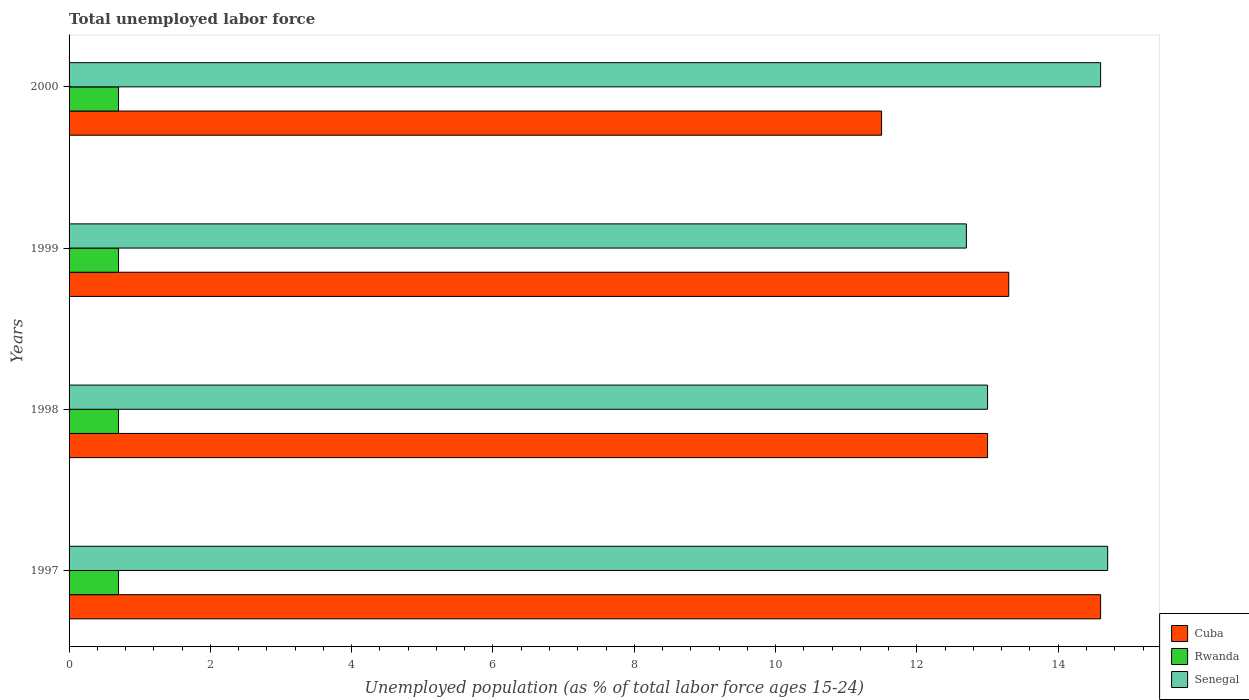How many different coloured bars are there?
Your answer should be very brief. 3. What is the label of the 4th group of bars from the top?
Provide a short and direct response. 1997. In how many cases, is the number of bars for a given year not equal to the number of legend labels?
Your response must be concise. 0. What is the percentage of unemployed population in in Rwanda in 1997?
Your answer should be compact. 0.7. Across all years, what is the maximum percentage of unemployed population in in Senegal?
Ensure brevity in your answer.  14.7. Across all years, what is the minimum percentage of unemployed population in in Senegal?
Your response must be concise. 12.7. In which year was the percentage of unemployed population in in Rwanda maximum?
Your response must be concise. 1997. In which year was the percentage of unemployed population in in Rwanda minimum?
Offer a terse response. 1997. What is the total percentage of unemployed population in in Cuba in the graph?
Provide a succinct answer. 52.4. What is the average percentage of unemployed population in in Cuba per year?
Provide a short and direct response. 13.1. In the year 2000, what is the difference between the percentage of unemployed population in in Senegal and percentage of unemployed population in in Rwanda?
Offer a terse response. 13.9. What is the ratio of the percentage of unemployed population in in Cuba in 1997 to that in 1999?
Your response must be concise. 1.1. Is the percentage of unemployed population in in Senegal in 1997 less than that in 1999?
Keep it short and to the point. No. What is the difference between the highest and the second highest percentage of unemployed population in in Senegal?
Give a very brief answer. 0.1. What is the difference between the highest and the lowest percentage of unemployed population in in Rwanda?
Your answer should be compact. 0. In how many years, is the percentage of unemployed population in in Senegal greater than the average percentage of unemployed population in in Senegal taken over all years?
Make the answer very short. 2. Is the sum of the percentage of unemployed population in in Cuba in 1997 and 1998 greater than the maximum percentage of unemployed population in in Rwanda across all years?
Provide a succinct answer. Yes. What does the 1st bar from the top in 1999 represents?
Give a very brief answer. Senegal. What does the 3rd bar from the bottom in 1997 represents?
Give a very brief answer. Senegal. Is it the case that in every year, the sum of the percentage of unemployed population in in Senegal and percentage of unemployed population in in Cuba is greater than the percentage of unemployed population in in Rwanda?
Your answer should be very brief. Yes. How many bars are there?
Give a very brief answer. 12. Are all the bars in the graph horizontal?
Give a very brief answer. Yes. What is the difference between two consecutive major ticks on the X-axis?
Provide a short and direct response. 2. Where does the legend appear in the graph?
Keep it short and to the point. Bottom right. How many legend labels are there?
Make the answer very short. 3. What is the title of the graph?
Your answer should be compact. Total unemployed labor force. Does "Armenia" appear as one of the legend labels in the graph?
Your response must be concise. No. What is the label or title of the X-axis?
Make the answer very short. Unemployed population (as % of total labor force ages 15-24). What is the label or title of the Y-axis?
Keep it short and to the point. Years. What is the Unemployed population (as % of total labor force ages 15-24) of Cuba in 1997?
Your response must be concise. 14.6. What is the Unemployed population (as % of total labor force ages 15-24) of Rwanda in 1997?
Make the answer very short. 0.7. What is the Unemployed population (as % of total labor force ages 15-24) in Senegal in 1997?
Provide a succinct answer. 14.7. What is the Unemployed population (as % of total labor force ages 15-24) of Rwanda in 1998?
Your response must be concise. 0.7. What is the Unemployed population (as % of total labor force ages 15-24) of Senegal in 1998?
Make the answer very short. 13. What is the Unemployed population (as % of total labor force ages 15-24) in Cuba in 1999?
Provide a succinct answer. 13.3. What is the Unemployed population (as % of total labor force ages 15-24) of Rwanda in 1999?
Offer a very short reply. 0.7. What is the Unemployed population (as % of total labor force ages 15-24) of Senegal in 1999?
Ensure brevity in your answer.  12.7. What is the Unemployed population (as % of total labor force ages 15-24) in Rwanda in 2000?
Give a very brief answer. 0.7. What is the Unemployed population (as % of total labor force ages 15-24) in Senegal in 2000?
Make the answer very short. 14.6. Across all years, what is the maximum Unemployed population (as % of total labor force ages 15-24) of Cuba?
Provide a short and direct response. 14.6. Across all years, what is the maximum Unemployed population (as % of total labor force ages 15-24) in Rwanda?
Make the answer very short. 0.7. Across all years, what is the maximum Unemployed population (as % of total labor force ages 15-24) in Senegal?
Make the answer very short. 14.7. Across all years, what is the minimum Unemployed population (as % of total labor force ages 15-24) in Cuba?
Give a very brief answer. 11.5. Across all years, what is the minimum Unemployed population (as % of total labor force ages 15-24) of Rwanda?
Give a very brief answer. 0.7. Across all years, what is the minimum Unemployed population (as % of total labor force ages 15-24) in Senegal?
Give a very brief answer. 12.7. What is the total Unemployed population (as % of total labor force ages 15-24) in Cuba in the graph?
Your response must be concise. 52.4. What is the total Unemployed population (as % of total labor force ages 15-24) of Rwanda in the graph?
Your answer should be compact. 2.8. What is the difference between the Unemployed population (as % of total labor force ages 15-24) of Cuba in 1997 and that in 1998?
Offer a very short reply. 1.6. What is the difference between the Unemployed population (as % of total labor force ages 15-24) in Cuba in 1997 and that in 1999?
Offer a very short reply. 1.3. What is the difference between the Unemployed population (as % of total labor force ages 15-24) in Rwanda in 1997 and that in 1999?
Your answer should be compact. 0. What is the difference between the Unemployed population (as % of total labor force ages 15-24) of Senegal in 1997 and that in 1999?
Offer a very short reply. 2. What is the difference between the Unemployed population (as % of total labor force ages 15-24) of Senegal in 1997 and that in 2000?
Your answer should be compact. 0.1. What is the difference between the Unemployed population (as % of total labor force ages 15-24) of Cuba in 1998 and that in 1999?
Offer a very short reply. -0.3. What is the difference between the Unemployed population (as % of total labor force ages 15-24) of Rwanda in 1998 and that in 1999?
Make the answer very short. 0. What is the difference between the Unemployed population (as % of total labor force ages 15-24) in Cuba in 1998 and that in 2000?
Your answer should be very brief. 1.5. What is the difference between the Unemployed population (as % of total labor force ages 15-24) of Rwanda in 1998 and that in 2000?
Your answer should be compact. 0. What is the difference between the Unemployed population (as % of total labor force ages 15-24) in Senegal in 1998 and that in 2000?
Your answer should be very brief. -1.6. What is the difference between the Unemployed population (as % of total labor force ages 15-24) in Rwanda in 1999 and that in 2000?
Provide a short and direct response. 0. What is the difference between the Unemployed population (as % of total labor force ages 15-24) of Cuba in 1997 and the Unemployed population (as % of total labor force ages 15-24) of Rwanda in 1998?
Keep it short and to the point. 13.9. What is the difference between the Unemployed population (as % of total labor force ages 15-24) of Cuba in 1997 and the Unemployed population (as % of total labor force ages 15-24) of Rwanda in 1999?
Give a very brief answer. 13.9. What is the difference between the Unemployed population (as % of total labor force ages 15-24) in Rwanda in 1997 and the Unemployed population (as % of total labor force ages 15-24) in Senegal in 1999?
Offer a very short reply. -12. What is the difference between the Unemployed population (as % of total labor force ages 15-24) of Cuba in 1997 and the Unemployed population (as % of total labor force ages 15-24) of Senegal in 2000?
Provide a succinct answer. 0. What is the difference between the Unemployed population (as % of total labor force ages 15-24) in Rwanda in 1997 and the Unemployed population (as % of total labor force ages 15-24) in Senegal in 2000?
Offer a very short reply. -13.9. What is the difference between the Unemployed population (as % of total labor force ages 15-24) in Cuba in 1998 and the Unemployed population (as % of total labor force ages 15-24) in Rwanda in 1999?
Provide a succinct answer. 12.3. What is the difference between the Unemployed population (as % of total labor force ages 15-24) of Cuba in 1998 and the Unemployed population (as % of total labor force ages 15-24) of Senegal in 1999?
Provide a succinct answer. 0.3. What is the difference between the Unemployed population (as % of total labor force ages 15-24) of Cuba in 1998 and the Unemployed population (as % of total labor force ages 15-24) of Rwanda in 2000?
Ensure brevity in your answer.  12.3. What is the difference between the Unemployed population (as % of total labor force ages 15-24) in Cuba in 1999 and the Unemployed population (as % of total labor force ages 15-24) in Rwanda in 2000?
Your response must be concise. 12.6. What is the difference between the Unemployed population (as % of total labor force ages 15-24) in Rwanda in 1999 and the Unemployed population (as % of total labor force ages 15-24) in Senegal in 2000?
Keep it short and to the point. -13.9. What is the average Unemployed population (as % of total labor force ages 15-24) of Rwanda per year?
Your answer should be very brief. 0.7. What is the average Unemployed population (as % of total labor force ages 15-24) of Senegal per year?
Your answer should be compact. 13.75. In the year 1997, what is the difference between the Unemployed population (as % of total labor force ages 15-24) in Cuba and Unemployed population (as % of total labor force ages 15-24) in Senegal?
Your answer should be compact. -0.1. In the year 1997, what is the difference between the Unemployed population (as % of total labor force ages 15-24) in Rwanda and Unemployed population (as % of total labor force ages 15-24) in Senegal?
Provide a short and direct response. -14. In the year 1998, what is the difference between the Unemployed population (as % of total labor force ages 15-24) of Cuba and Unemployed population (as % of total labor force ages 15-24) of Rwanda?
Make the answer very short. 12.3. In the year 1999, what is the difference between the Unemployed population (as % of total labor force ages 15-24) in Cuba and Unemployed population (as % of total labor force ages 15-24) in Rwanda?
Provide a succinct answer. 12.6. In the year 1999, what is the difference between the Unemployed population (as % of total labor force ages 15-24) of Cuba and Unemployed population (as % of total labor force ages 15-24) of Senegal?
Provide a succinct answer. 0.6. In the year 1999, what is the difference between the Unemployed population (as % of total labor force ages 15-24) in Rwanda and Unemployed population (as % of total labor force ages 15-24) in Senegal?
Your answer should be compact. -12. In the year 2000, what is the difference between the Unemployed population (as % of total labor force ages 15-24) of Cuba and Unemployed population (as % of total labor force ages 15-24) of Rwanda?
Provide a short and direct response. 10.8. In the year 2000, what is the difference between the Unemployed population (as % of total labor force ages 15-24) of Cuba and Unemployed population (as % of total labor force ages 15-24) of Senegal?
Your answer should be compact. -3.1. What is the ratio of the Unemployed population (as % of total labor force ages 15-24) of Cuba in 1997 to that in 1998?
Give a very brief answer. 1.12. What is the ratio of the Unemployed population (as % of total labor force ages 15-24) of Rwanda in 1997 to that in 1998?
Provide a short and direct response. 1. What is the ratio of the Unemployed population (as % of total labor force ages 15-24) in Senegal in 1997 to that in 1998?
Make the answer very short. 1.13. What is the ratio of the Unemployed population (as % of total labor force ages 15-24) in Cuba in 1997 to that in 1999?
Your answer should be very brief. 1.1. What is the ratio of the Unemployed population (as % of total labor force ages 15-24) in Senegal in 1997 to that in 1999?
Offer a very short reply. 1.16. What is the ratio of the Unemployed population (as % of total labor force ages 15-24) in Cuba in 1997 to that in 2000?
Give a very brief answer. 1.27. What is the ratio of the Unemployed population (as % of total labor force ages 15-24) of Senegal in 1997 to that in 2000?
Your answer should be very brief. 1.01. What is the ratio of the Unemployed population (as % of total labor force ages 15-24) of Cuba in 1998 to that in 1999?
Provide a short and direct response. 0.98. What is the ratio of the Unemployed population (as % of total labor force ages 15-24) of Rwanda in 1998 to that in 1999?
Offer a very short reply. 1. What is the ratio of the Unemployed population (as % of total labor force ages 15-24) of Senegal in 1998 to that in 1999?
Your answer should be compact. 1.02. What is the ratio of the Unemployed population (as % of total labor force ages 15-24) of Cuba in 1998 to that in 2000?
Keep it short and to the point. 1.13. What is the ratio of the Unemployed population (as % of total labor force ages 15-24) of Rwanda in 1998 to that in 2000?
Make the answer very short. 1. What is the ratio of the Unemployed population (as % of total labor force ages 15-24) of Senegal in 1998 to that in 2000?
Ensure brevity in your answer.  0.89. What is the ratio of the Unemployed population (as % of total labor force ages 15-24) of Cuba in 1999 to that in 2000?
Provide a short and direct response. 1.16. What is the ratio of the Unemployed population (as % of total labor force ages 15-24) of Rwanda in 1999 to that in 2000?
Offer a very short reply. 1. What is the ratio of the Unemployed population (as % of total labor force ages 15-24) in Senegal in 1999 to that in 2000?
Keep it short and to the point. 0.87. What is the difference between the highest and the second highest Unemployed population (as % of total labor force ages 15-24) in Senegal?
Make the answer very short. 0.1. What is the difference between the highest and the lowest Unemployed population (as % of total labor force ages 15-24) in Rwanda?
Make the answer very short. 0. What is the difference between the highest and the lowest Unemployed population (as % of total labor force ages 15-24) in Senegal?
Offer a terse response. 2. 